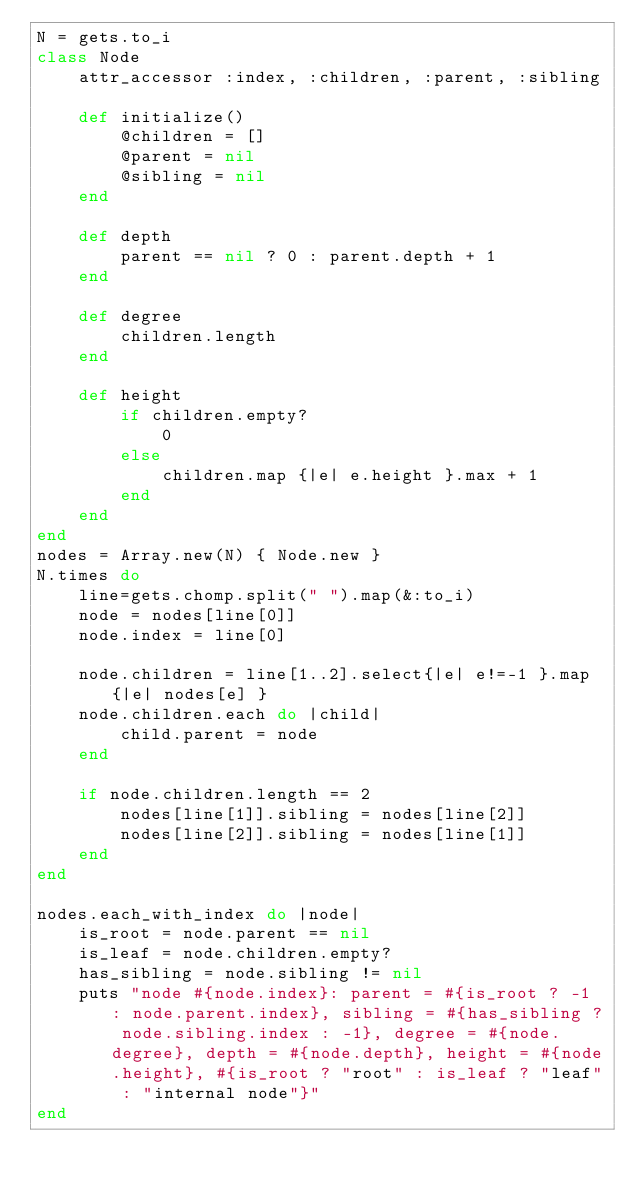<code> <loc_0><loc_0><loc_500><loc_500><_Ruby_>N = gets.to_i
class Node
    attr_accessor :index, :children, :parent, :sibling

    def initialize()
        @children = []
        @parent = nil
        @sibling = nil
    end

    def depth
        parent == nil ? 0 : parent.depth + 1
    end

    def degree
        children.length
    end

    def height
        if children.empty?
            0
        else
            children.map {|e| e.height }.max + 1
        end
    end
end
nodes = Array.new(N) { Node.new }
N.times do
    line=gets.chomp.split(" ").map(&:to_i)
    node = nodes[line[0]]
    node.index = line[0]
    
    node.children = line[1..2].select{|e| e!=-1 }.map {|e| nodes[e] }
    node.children.each do |child|
        child.parent = node
    end

    if node.children.length == 2
        nodes[line[1]].sibling = nodes[line[2]]
        nodes[line[2]].sibling = nodes[line[1]]
    end
end

nodes.each_with_index do |node|
    is_root = node.parent == nil
    is_leaf = node.children.empty?
    has_sibling = node.sibling != nil
    puts "node #{node.index}: parent = #{is_root ? -1 : node.parent.index}, sibling = #{has_sibling ? node.sibling.index : -1}, degree = #{node.degree}, depth = #{node.depth}, height = #{node.height}, #{is_root ? "root" : is_leaf ? "leaf" : "internal node"}"
end
</code> 